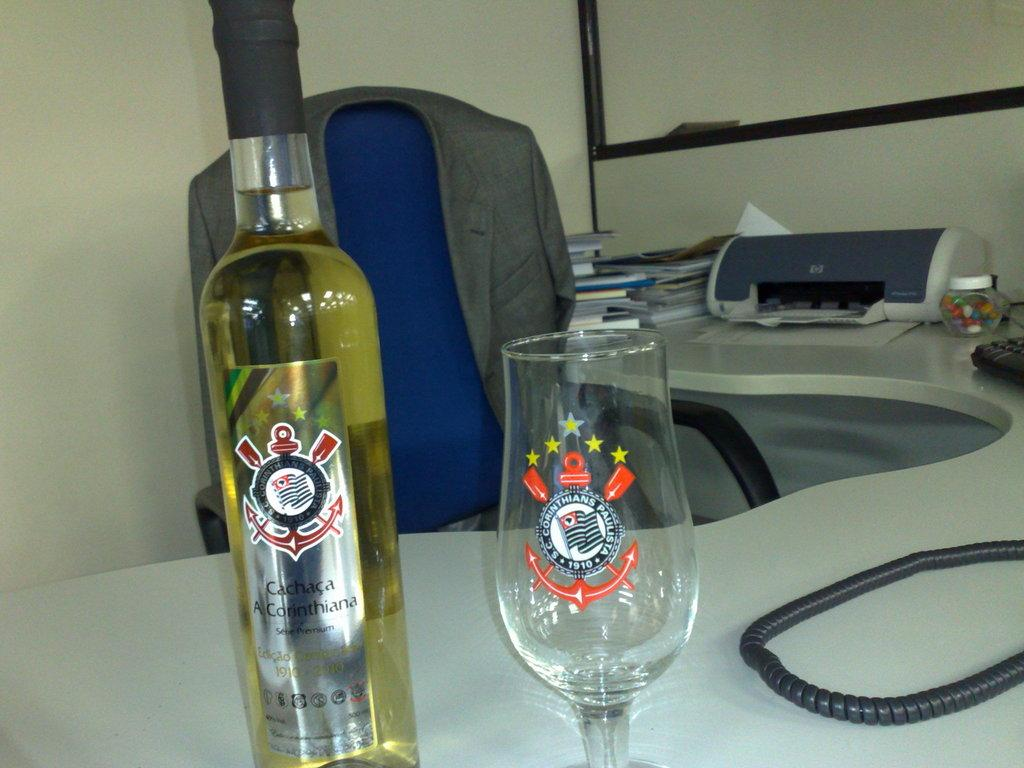Provide a one-sentence caption for the provided image. An office desk with a bottle of Cachaca and a decorative glass. 